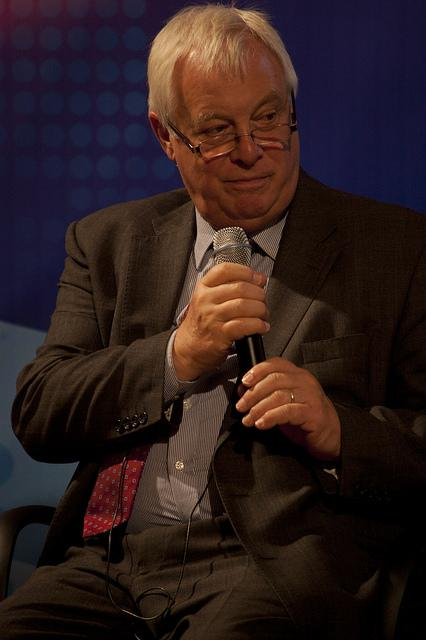What is he about to do? Please explain your reasoning. speak. Given that he's holding a microphone, this is the most likely option. 